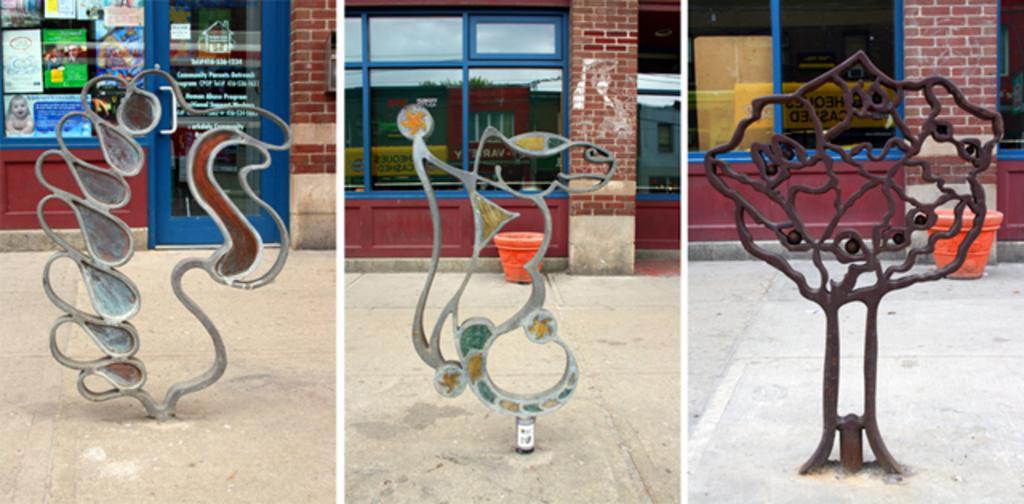Please provide a concise description of this image. In this picture there are three images, where we can see three symbolized structures made up of iron and in the background, there is a wall in all three images. 